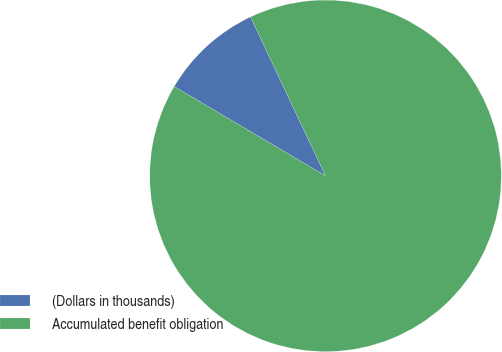Convert chart to OTSL. <chart><loc_0><loc_0><loc_500><loc_500><pie_chart><fcel>(Dollars in thousands)<fcel>Accumulated benefit obligation<nl><fcel>9.5%<fcel>90.5%<nl></chart> 